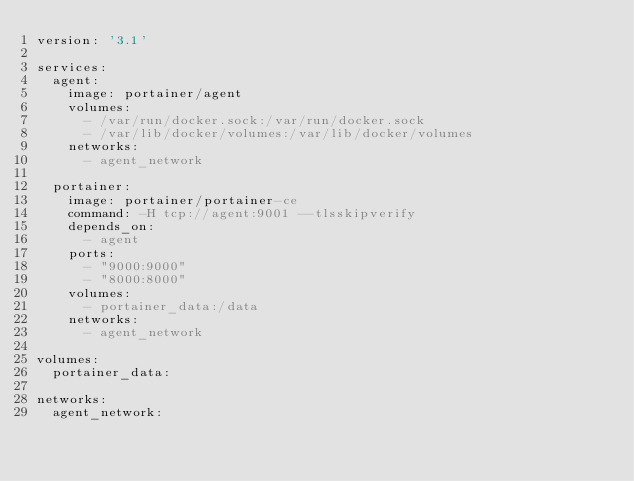Convert code to text. <code><loc_0><loc_0><loc_500><loc_500><_YAML_>version: '3.1'

services:
  agent:
    image: portainer/agent
    volumes:
      - /var/run/docker.sock:/var/run/docker.sock
      - /var/lib/docker/volumes:/var/lib/docker/volumes
    networks:
      - agent_network

  portainer:
    image: portainer/portainer-ce
    command: -H tcp://agent:9001 --tlsskipverify
    depends_on:
      - agent
    ports:
      - "9000:9000"
      - "8000:8000"
    volumes:
      - portainer_data:/data
    networks:
      - agent_network

volumes:
  portainer_data:

networks:
  agent_network:
</code> 